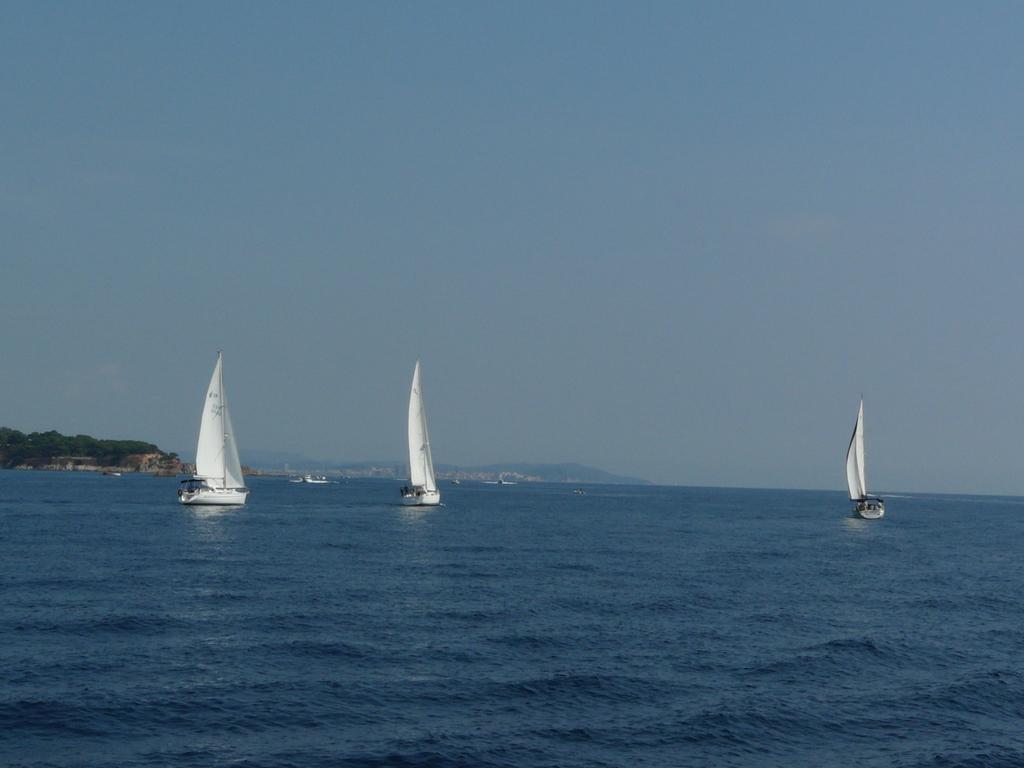What is on the water in the image? There are boats on the water in the image. What type of natural landscape can be seen in the image? There are mountains and trees visible in the image. What is visible in the background of the image? The sky is visible in the background of the image. What type of zinc can be seen in the image? There is no zinc present in the image. How many stars are visible in the image? The image does not show any stars; it only shows boats, water, mountains, trees, and the sky. 